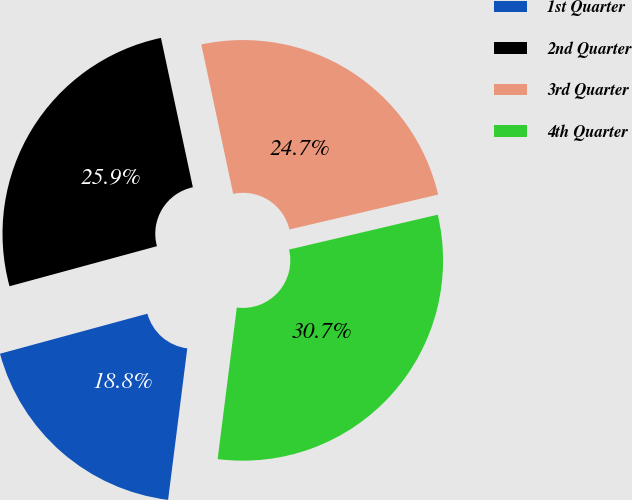Convert chart. <chart><loc_0><loc_0><loc_500><loc_500><pie_chart><fcel>1st Quarter<fcel>2nd Quarter<fcel>3rd Quarter<fcel>4th Quarter<nl><fcel>18.77%<fcel>25.87%<fcel>24.68%<fcel>30.67%<nl></chart> 